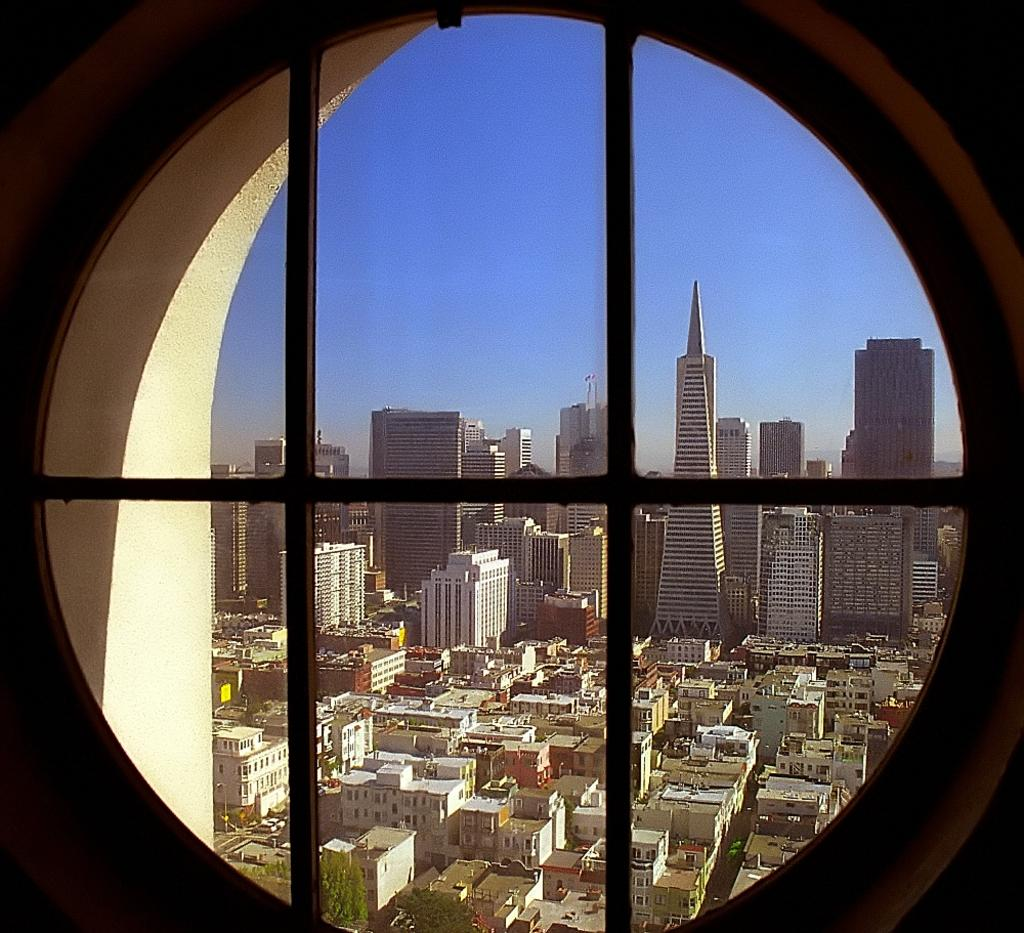What shape is present in the image? There is a circle in the image. What can be seen through the circle? Buildings and the sky are visible through the circle. How many cats are sitting on the account in the image? There are no cats or accounts present in the image. What type of cracker is being used to create the circle in the image? There is no cracker present in the image; the circle is not created by any cracker. 